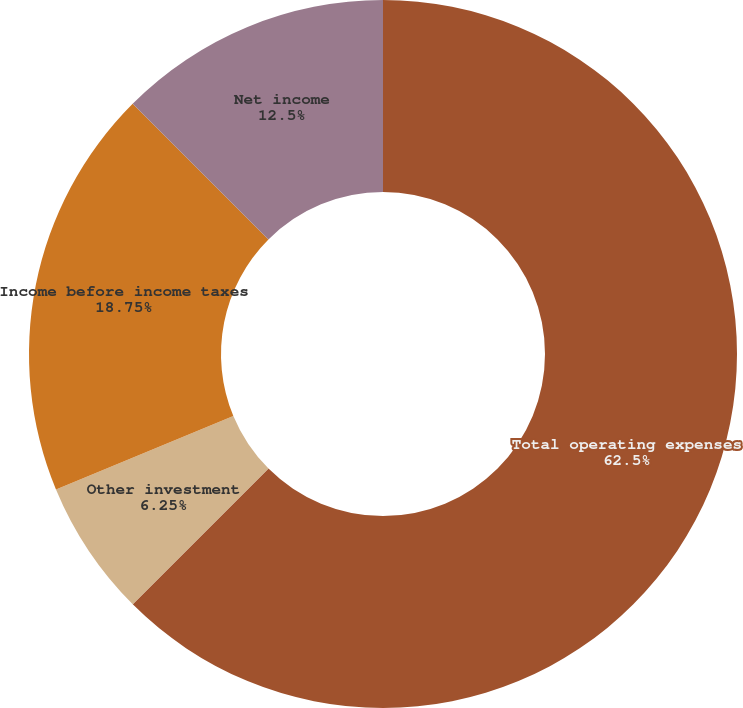<chart> <loc_0><loc_0><loc_500><loc_500><pie_chart><fcel>Total operating expenses<fcel>Other investment<fcel>Income before income taxes<fcel>Net income<fcel>(Gains)/losses attributable to<nl><fcel>62.49%<fcel>6.25%<fcel>18.75%<fcel>12.5%<fcel>0.0%<nl></chart> 